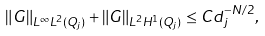<formula> <loc_0><loc_0><loc_500><loc_500>& \| G \| _ { L ^ { \infty } L ^ { 2 } ( Q _ { j } ) } + \| G \| _ { L ^ { 2 } H ^ { 1 } ( Q _ { j } ) } \leq C d _ { j } ^ { - N / 2 } ,</formula> 